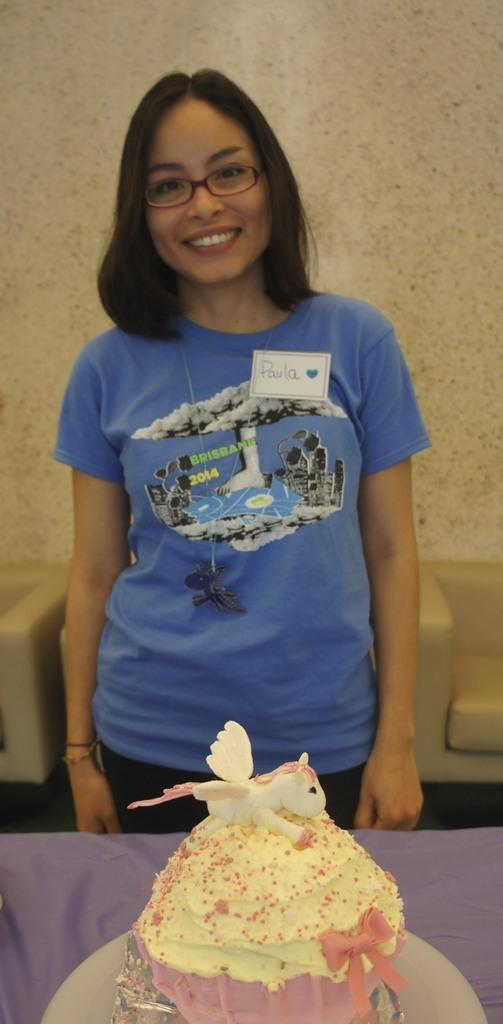Who is the main subject in the image? There is a girl in the center of the image. What is located in front of the girl? There is a cake in front of the girl. What can be seen in the background of the image? There is a sofa in the background of the image. What type of root can be seen growing from the cake in the image? There is no root growing from the cake in the image; it is a cake without any roots. 